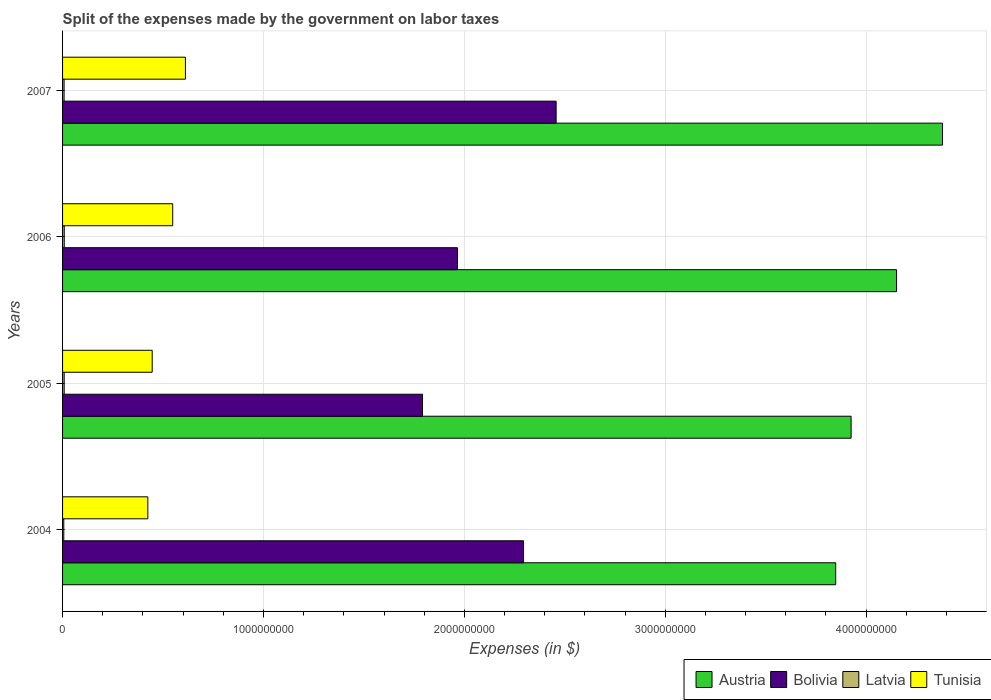Are the number of bars per tick equal to the number of legend labels?
Offer a very short reply. Yes. Are the number of bars on each tick of the Y-axis equal?
Your answer should be compact. Yes. How many bars are there on the 3rd tick from the top?
Offer a very short reply. 4. How many bars are there on the 4th tick from the bottom?
Ensure brevity in your answer.  4. In how many cases, is the number of bars for a given year not equal to the number of legend labels?
Your answer should be compact. 0. What is the expenses made by the government on labor taxes in Tunisia in 2006?
Your answer should be very brief. 5.48e+08. Across all years, what is the maximum expenses made by the government on labor taxes in Latvia?
Offer a very short reply. 8.40e+06. Across all years, what is the minimum expenses made by the government on labor taxes in Austria?
Your answer should be very brief. 3.85e+09. What is the total expenses made by the government on labor taxes in Latvia in the graph?
Your answer should be very brief. 3.02e+07. What is the difference between the expenses made by the government on labor taxes in Austria in 2004 and that in 2007?
Keep it short and to the point. -5.32e+08. What is the difference between the expenses made by the government on labor taxes in Tunisia in 2005 and the expenses made by the government on labor taxes in Latvia in 2007?
Your answer should be very brief. 4.38e+08. What is the average expenses made by the government on labor taxes in Tunisia per year?
Your response must be concise. 5.08e+08. In the year 2006, what is the difference between the expenses made by the government on labor taxes in Bolivia and expenses made by the government on labor taxes in Latvia?
Your answer should be very brief. 1.96e+09. What is the ratio of the expenses made by the government on labor taxes in Austria in 2005 to that in 2006?
Ensure brevity in your answer.  0.95. Is the expenses made by the government on labor taxes in Tunisia in 2004 less than that in 2005?
Your answer should be very brief. Yes. Is the difference between the expenses made by the government on labor taxes in Bolivia in 2006 and 2007 greater than the difference between the expenses made by the government on labor taxes in Latvia in 2006 and 2007?
Your answer should be very brief. No. What is the difference between the highest and the second highest expenses made by the government on labor taxes in Bolivia?
Your answer should be very brief. 1.62e+08. What is the difference between the highest and the lowest expenses made by the government on labor taxes in Bolivia?
Your answer should be compact. 6.65e+08. In how many years, is the expenses made by the government on labor taxes in Austria greater than the average expenses made by the government on labor taxes in Austria taken over all years?
Give a very brief answer. 2. Is it the case that in every year, the sum of the expenses made by the government on labor taxes in Austria and expenses made by the government on labor taxes in Bolivia is greater than the sum of expenses made by the government on labor taxes in Tunisia and expenses made by the government on labor taxes in Latvia?
Your answer should be very brief. Yes. What does the 1st bar from the bottom in 2007 represents?
Keep it short and to the point. Austria. How many bars are there?
Ensure brevity in your answer.  16. How many years are there in the graph?
Your answer should be very brief. 4. Are the values on the major ticks of X-axis written in scientific E-notation?
Keep it short and to the point. No. Does the graph contain any zero values?
Provide a succinct answer. No. Does the graph contain grids?
Offer a terse response. Yes. Where does the legend appear in the graph?
Give a very brief answer. Bottom right. What is the title of the graph?
Your response must be concise. Split of the expenses made by the government on labor taxes. Does "Malawi" appear as one of the legend labels in the graph?
Offer a very short reply. No. What is the label or title of the X-axis?
Offer a very short reply. Expenses (in $). What is the label or title of the Y-axis?
Keep it short and to the point. Years. What is the Expenses (in $) in Austria in 2004?
Provide a short and direct response. 3.85e+09. What is the Expenses (in $) in Bolivia in 2004?
Keep it short and to the point. 2.29e+09. What is the Expenses (in $) of Latvia in 2004?
Your answer should be very brief. 6.10e+06. What is the Expenses (in $) in Tunisia in 2004?
Ensure brevity in your answer.  4.24e+08. What is the Expenses (in $) of Austria in 2005?
Keep it short and to the point. 3.93e+09. What is the Expenses (in $) in Bolivia in 2005?
Give a very brief answer. 1.79e+09. What is the Expenses (in $) of Latvia in 2005?
Ensure brevity in your answer.  8.10e+06. What is the Expenses (in $) of Tunisia in 2005?
Provide a short and direct response. 4.46e+08. What is the Expenses (in $) of Austria in 2006?
Provide a short and direct response. 4.15e+09. What is the Expenses (in $) of Bolivia in 2006?
Offer a terse response. 1.97e+09. What is the Expenses (in $) of Latvia in 2006?
Offer a very short reply. 8.40e+06. What is the Expenses (in $) in Tunisia in 2006?
Offer a terse response. 5.48e+08. What is the Expenses (in $) of Austria in 2007?
Your answer should be compact. 4.38e+09. What is the Expenses (in $) in Bolivia in 2007?
Offer a terse response. 2.46e+09. What is the Expenses (in $) in Latvia in 2007?
Provide a short and direct response. 7.61e+06. What is the Expenses (in $) in Tunisia in 2007?
Give a very brief answer. 6.12e+08. Across all years, what is the maximum Expenses (in $) in Austria?
Offer a terse response. 4.38e+09. Across all years, what is the maximum Expenses (in $) in Bolivia?
Ensure brevity in your answer.  2.46e+09. Across all years, what is the maximum Expenses (in $) in Latvia?
Offer a very short reply. 8.40e+06. Across all years, what is the maximum Expenses (in $) in Tunisia?
Your answer should be compact. 6.12e+08. Across all years, what is the minimum Expenses (in $) of Austria?
Ensure brevity in your answer.  3.85e+09. Across all years, what is the minimum Expenses (in $) of Bolivia?
Provide a succinct answer. 1.79e+09. Across all years, what is the minimum Expenses (in $) of Latvia?
Provide a short and direct response. 6.10e+06. Across all years, what is the minimum Expenses (in $) of Tunisia?
Your answer should be very brief. 4.24e+08. What is the total Expenses (in $) of Austria in the graph?
Give a very brief answer. 1.63e+1. What is the total Expenses (in $) in Bolivia in the graph?
Make the answer very short. 8.51e+09. What is the total Expenses (in $) in Latvia in the graph?
Offer a terse response. 3.02e+07. What is the total Expenses (in $) in Tunisia in the graph?
Keep it short and to the point. 2.03e+09. What is the difference between the Expenses (in $) of Austria in 2004 and that in 2005?
Your response must be concise. -7.66e+07. What is the difference between the Expenses (in $) of Bolivia in 2004 and that in 2005?
Your response must be concise. 5.03e+08. What is the difference between the Expenses (in $) in Latvia in 2004 and that in 2005?
Keep it short and to the point. -2.00e+06. What is the difference between the Expenses (in $) of Tunisia in 2004 and that in 2005?
Offer a terse response. -2.17e+07. What is the difference between the Expenses (in $) in Austria in 2004 and that in 2006?
Ensure brevity in your answer.  -3.03e+08. What is the difference between the Expenses (in $) in Bolivia in 2004 and that in 2006?
Your answer should be compact. 3.29e+08. What is the difference between the Expenses (in $) in Latvia in 2004 and that in 2006?
Offer a very short reply. -2.30e+06. What is the difference between the Expenses (in $) in Tunisia in 2004 and that in 2006?
Ensure brevity in your answer.  -1.24e+08. What is the difference between the Expenses (in $) of Austria in 2004 and that in 2007?
Keep it short and to the point. -5.32e+08. What is the difference between the Expenses (in $) of Bolivia in 2004 and that in 2007?
Give a very brief answer. -1.62e+08. What is the difference between the Expenses (in $) in Latvia in 2004 and that in 2007?
Your answer should be very brief. -1.51e+06. What is the difference between the Expenses (in $) of Tunisia in 2004 and that in 2007?
Your answer should be compact. -1.87e+08. What is the difference between the Expenses (in $) in Austria in 2005 and that in 2006?
Provide a short and direct response. -2.26e+08. What is the difference between the Expenses (in $) of Bolivia in 2005 and that in 2006?
Ensure brevity in your answer.  -1.74e+08. What is the difference between the Expenses (in $) in Latvia in 2005 and that in 2006?
Your answer should be very brief. -3.00e+05. What is the difference between the Expenses (in $) in Tunisia in 2005 and that in 2006?
Offer a terse response. -1.02e+08. What is the difference between the Expenses (in $) of Austria in 2005 and that in 2007?
Provide a succinct answer. -4.55e+08. What is the difference between the Expenses (in $) in Bolivia in 2005 and that in 2007?
Ensure brevity in your answer.  -6.65e+08. What is the difference between the Expenses (in $) of Tunisia in 2005 and that in 2007?
Keep it short and to the point. -1.65e+08. What is the difference between the Expenses (in $) of Austria in 2006 and that in 2007?
Give a very brief answer. -2.29e+08. What is the difference between the Expenses (in $) of Bolivia in 2006 and that in 2007?
Ensure brevity in your answer.  -4.91e+08. What is the difference between the Expenses (in $) in Latvia in 2006 and that in 2007?
Offer a terse response. 7.90e+05. What is the difference between the Expenses (in $) of Tunisia in 2006 and that in 2007?
Offer a very short reply. -6.33e+07. What is the difference between the Expenses (in $) of Austria in 2004 and the Expenses (in $) of Bolivia in 2005?
Ensure brevity in your answer.  2.06e+09. What is the difference between the Expenses (in $) of Austria in 2004 and the Expenses (in $) of Latvia in 2005?
Provide a short and direct response. 3.84e+09. What is the difference between the Expenses (in $) of Austria in 2004 and the Expenses (in $) of Tunisia in 2005?
Keep it short and to the point. 3.40e+09. What is the difference between the Expenses (in $) of Bolivia in 2004 and the Expenses (in $) of Latvia in 2005?
Provide a succinct answer. 2.29e+09. What is the difference between the Expenses (in $) of Bolivia in 2004 and the Expenses (in $) of Tunisia in 2005?
Your answer should be compact. 1.85e+09. What is the difference between the Expenses (in $) of Latvia in 2004 and the Expenses (in $) of Tunisia in 2005?
Provide a succinct answer. -4.40e+08. What is the difference between the Expenses (in $) of Austria in 2004 and the Expenses (in $) of Bolivia in 2006?
Keep it short and to the point. 1.88e+09. What is the difference between the Expenses (in $) in Austria in 2004 and the Expenses (in $) in Latvia in 2006?
Provide a short and direct response. 3.84e+09. What is the difference between the Expenses (in $) of Austria in 2004 and the Expenses (in $) of Tunisia in 2006?
Offer a terse response. 3.30e+09. What is the difference between the Expenses (in $) of Bolivia in 2004 and the Expenses (in $) of Latvia in 2006?
Provide a succinct answer. 2.29e+09. What is the difference between the Expenses (in $) in Bolivia in 2004 and the Expenses (in $) in Tunisia in 2006?
Provide a short and direct response. 1.75e+09. What is the difference between the Expenses (in $) in Latvia in 2004 and the Expenses (in $) in Tunisia in 2006?
Offer a very short reply. -5.42e+08. What is the difference between the Expenses (in $) in Austria in 2004 and the Expenses (in $) in Bolivia in 2007?
Your response must be concise. 1.39e+09. What is the difference between the Expenses (in $) of Austria in 2004 and the Expenses (in $) of Latvia in 2007?
Make the answer very short. 3.84e+09. What is the difference between the Expenses (in $) of Austria in 2004 and the Expenses (in $) of Tunisia in 2007?
Keep it short and to the point. 3.24e+09. What is the difference between the Expenses (in $) in Bolivia in 2004 and the Expenses (in $) in Latvia in 2007?
Keep it short and to the point. 2.29e+09. What is the difference between the Expenses (in $) of Bolivia in 2004 and the Expenses (in $) of Tunisia in 2007?
Provide a short and direct response. 1.68e+09. What is the difference between the Expenses (in $) in Latvia in 2004 and the Expenses (in $) in Tunisia in 2007?
Provide a short and direct response. -6.05e+08. What is the difference between the Expenses (in $) of Austria in 2005 and the Expenses (in $) of Bolivia in 2006?
Offer a very short reply. 1.96e+09. What is the difference between the Expenses (in $) of Austria in 2005 and the Expenses (in $) of Latvia in 2006?
Provide a succinct answer. 3.92e+09. What is the difference between the Expenses (in $) in Austria in 2005 and the Expenses (in $) in Tunisia in 2006?
Your answer should be compact. 3.38e+09. What is the difference between the Expenses (in $) in Bolivia in 2005 and the Expenses (in $) in Latvia in 2006?
Your response must be concise. 1.78e+09. What is the difference between the Expenses (in $) in Bolivia in 2005 and the Expenses (in $) in Tunisia in 2006?
Your answer should be compact. 1.24e+09. What is the difference between the Expenses (in $) of Latvia in 2005 and the Expenses (in $) of Tunisia in 2006?
Provide a succinct answer. -5.40e+08. What is the difference between the Expenses (in $) of Austria in 2005 and the Expenses (in $) of Bolivia in 2007?
Give a very brief answer. 1.47e+09. What is the difference between the Expenses (in $) of Austria in 2005 and the Expenses (in $) of Latvia in 2007?
Your answer should be very brief. 3.92e+09. What is the difference between the Expenses (in $) of Austria in 2005 and the Expenses (in $) of Tunisia in 2007?
Your answer should be very brief. 3.31e+09. What is the difference between the Expenses (in $) of Bolivia in 2005 and the Expenses (in $) of Latvia in 2007?
Provide a succinct answer. 1.78e+09. What is the difference between the Expenses (in $) of Bolivia in 2005 and the Expenses (in $) of Tunisia in 2007?
Your answer should be compact. 1.18e+09. What is the difference between the Expenses (in $) of Latvia in 2005 and the Expenses (in $) of Tunisia in 2007?
Provide a short and direct response. -6.03e+08. What is the difference between the Expenses (in $) in Austria in 2006 and the Expenses (in $) in Bolivia in 2007?
Your answer should be compact. 1.69e+09. What is the difference between the Expenses (in $) of Austria in 2006 and the Expenses (in $) of Latvia in 2007?
Ensure brevity in your answer.  4.14e+09. What is the difference between the Expenses (in $) of Austria in 2006 and the Expenses (in $) of Tunisia in 2007?
Give a very brief answer. 3.54e+09. What is the difference between the Expenses (in $) of Bolivia in 2006 and the Expenses (in $) of Latvia in 2007?
Your response must be concise. 1.96e+09. What is the difference between the Expenses (in $) in Bolivia in 2006 and the Expenses (in $) in Tunisia in 2007?
Make the answer very short. 1.35e+09. What is the difference between the Expenses (in $) of Latvia in 2006 and the Expenses (in $) of Tunisia in 2007?
Ensure brevity in your answer.  -6.03e+08. What is the average Expenses (in $) in Austria per year?
Give a very brief answer. 4.08e+09. What is the average Expenses (in $) of Bolivia per year?
Your response must be concise. 2.13e+09. What is the average Expenses (in $) of Latvia per year?
Your response must be concise. 7.55e+06. What is the average Expenses (in $) of Tunisia per year?
Your response must be concise. 5.08e+08. In the year 2004, what is the difference between the Expenses (in $) of Austria and Expenses (in $) of Bolivia?
Offer a terse response. 1.55e+09. In the year 2004, what is the difference between the Expenses (in $) in Austria and Expenses (in $) in Latvia?
Provide a succinct answer. 3.84e+09. In the year 2004, what is the difference between the Expenses (in $) in Austria and Expenses (in $) in Tunisia?
Your response must be concise. 3.42e+09. In the year 2004, what is the difference between the Expenses (in $) in Bolivia and Expenses (in $) in Latvia?
Keep it short and to the point. 2.29e+09. In the year 2004, what is the difference between the Expenses (in $) of Bolivia and Expenses (in $) of Tunisia?
Your response must be concise. 1.87e+09. In the year 2004, what is the difference between the Expenses (in $) of Latvia and Expenses (in $) of Tunisia?
Ensure brevity in your answer.  -4.18e+08. In the year 2005, what is the difference between the Expenses (in $) of Austria and Expenses (in $) of Bolivia?
Make the answer very short. 2.13e+09. In the year 2005, what is the difference between the Expenses (in $) of Austria and Expenses (in $) of Latvia?
Provide a short and direct response. 3.92e+09. In the year 2005, what is the difference between the Expenses (in $) in Austria and Expenses (in $) in Tunisia?
Your answer should be compact. 3.48e+09. In the year 2005, what is the difference between the Expenses (in $) of Bolivia and Expenses (in $) of Latvia?
Keep it short and to the point. 1.78e+09. In the year 2005, what is the difference between the Expenses (in $) of Bolivia and Expenses (in $) of Tunisia?
Provide a succinct answer. 1.35e+09. In the year 2005, what is the difference between the Expenses (in $) in Latvia and Expenses (in $) in Tunisia?
Keep it short and to the point. -4.38e+08. In the year 2006, what is the difference between the Expenses (in $) in Austria and Expenses (in $) in Bolivia?
Provide a succinct answer. 2.19e+09. In the year 2006, what is the difference between the Expenses (in $) of Austria and Expenses (in $) of Latvia?
Offer a terse response. 4.14e+09. In the year 2006, what is the difference between the Expenses (in $) of Austria and Expenses (in $) of Tunisia?
Your answer should be very brief. 3.60e+09. In the year 2006, what is the difference between the Expenses (in $) in Bolivia and Expenses (in $) in Latvia?
Offer a very short reply. 1.96e+09. In the year 2006, what is the difference between the Expenses (in $) in Bolivia and Expenses (in $) in Tunisia?
Provide a succinct answer. 1.42e+09. In the year 2006, what is the difference between the Expenses (in $) in Latvia and Expenses (in $) in Tunisia?
Your response must be concise. -5.40e+08. In the year 2007, what is the difference between the Expenses (in $) in Austria and Expenses (in $) in Bolivia?
Give a very brief answer. 1.92e+09. In the year 2007, what is the difference between the Expenses (in $) in Austria and Expenses (in $) in Latvia?
Your answer should be compact. 4.37e+09. In the year 2007, what is the difference between the Expenses (in $) of Austria and Expenses (in $) of Tunisia?
Provide a succinct answer. 3.77e+09. In the year 2007, what is the difference between the Expenses (in $) in Bolivia and Expenses (in $) in Latvia?
Provide a succinct answer. 2.45e+09. In the year 2007, what is the difference between the Expenses (in $) of Bolivia and Expenses (in $) of Tunisia?
Provide a short and direct response. 1.85e+09. In the year 2007, what is the difference between the Expenses (in $) of Latvia and Expenses (in $) of Tunisia?
Your answer should be compact. -6.04e+08. What is the ratio of the Expenses (in $) of Austria in 2004 to that in 2005?
Your response must be concise. 0.98. What is the ratio of the Expenses (in $) in Bolivia in 2004 to that in 2005?
Your answer should be very brief. 1.28. What is the ratio of the Expenses (in $) of Latvia in 2004 to that in 2005?
Your answer should be very brief. 0.75. What is the ratio of the Expenses (in $) in Tunisia in 2004 to that in 2005?
Give a very brief answer. 0.95. What is the ratio of the Expenses (in $) of Austria in 2004 to that in 2006?
Keep it short and to the point. 0.93. What is the ratio of the Expenses (in $) of Bolivia in 2004 to that in 2006?
Your answer should be very brief. 1.17. What is the ratio of the Expenses (in $) in Latvia in 2004 to that in 2006?
Your response must be concise. 0.73. What is the ratio of the Expenses (in $) of Tunisia in 2004 to that in 2006?
Keep it short and to the point. 0.77. What is the ratio of the Expenses (in $) in Austria in 2004 to that in 2007?
Provide a succinct answer. 0.88. What is the ratio of the Expenses (in $) of Bolivia in 2004 to that in 2007?
Your answer should be compact. 0.93. What is the ratio of the Expenses (in $) of Latvia in 2004 to that in 2007?
Give a very brief answer. 0.8. What is the ratio of the Expenses (in $) in Tunisia in 2004 to that in 2007?
Provide a succinct answer. 0.69. What is the ratio of the Expenses (in $) of Austria in 2005 to that in 2006?
Make the answer very short. 0.95. What is the ratio of the Expenses (in $) of Bolivia in 2005 to that in 2006?
Provide a succinct answer. 0.91. What is the ratio of the Expenses (in $) in Tunisia in 2005 to that in 2006?
Keep it short and to the point. 0.81. What is the ratio of the Expenses (in $) in Austria in 2005 to that in 2007?
Your answer should be compact. 0.9. What is the ratio of the Expenses (in $) of Bolivia in 2005 to that in 2007?
Provide a succinct answer. 0.73. What is the ratio of the Expenses (in $) of Latvia in 2005 to that in 2007?
Make the answer very short. 1.06. What is the ratio of the Expenses (in $) of Tunisia in 2005 to that in 2007?
Your answer should be compact. 0.73. What is the ratio of the Expenses (in $) of Austria in 2006 to that in 2007?
Provide a short and direct response. 0.95. What is the ratio of the Expenses (in $) of Bolivia in 2006 to that in 2007?
Your answer should be very brief. 0.8. What is the ratio of the Expenses (in $) of Latvia in 2006 to that in 2007?
Provide a succinct answer. 1.1. What is the ratio of the Expenses (in $) of Tunisia in 2006 to that in 2007?
Provide a short and direct response. 0.9. What is the difference between the highest and the second highest Expenses (in $) of Austria?
Your response must be concise. 2.29e+08. What is the difference between the highest and the second highest Expenses (in $) in Bolivia?
Provide a succinct answer. 1.62e+08. What is the difference between the highest and the second highest Expenses (in $) of Latvia?
Offer a very short reply. 3.00e+05. What is the difference between the highest and the second highest Expenses (in $) of Tunisia?
Provide a succinct answer. 6.33e+07. What is the difference between the highest and the lowest Expenses (in $) in Austria?
Give a very brief answer. 5.32e+08. What is the difference between the highest and the lowest Expenses (in $) in Bolivia?
Ensure brevity in your answer.  6.65e+08. What is the difference between the highest and the lowest Expenses (in $) in Latvia?
Make the answer very short. 2.30e+06. What is the difference between the highest and the lowest Expenses (in $) of Tunisia?
Make the answer very short. 1.87e+08. 